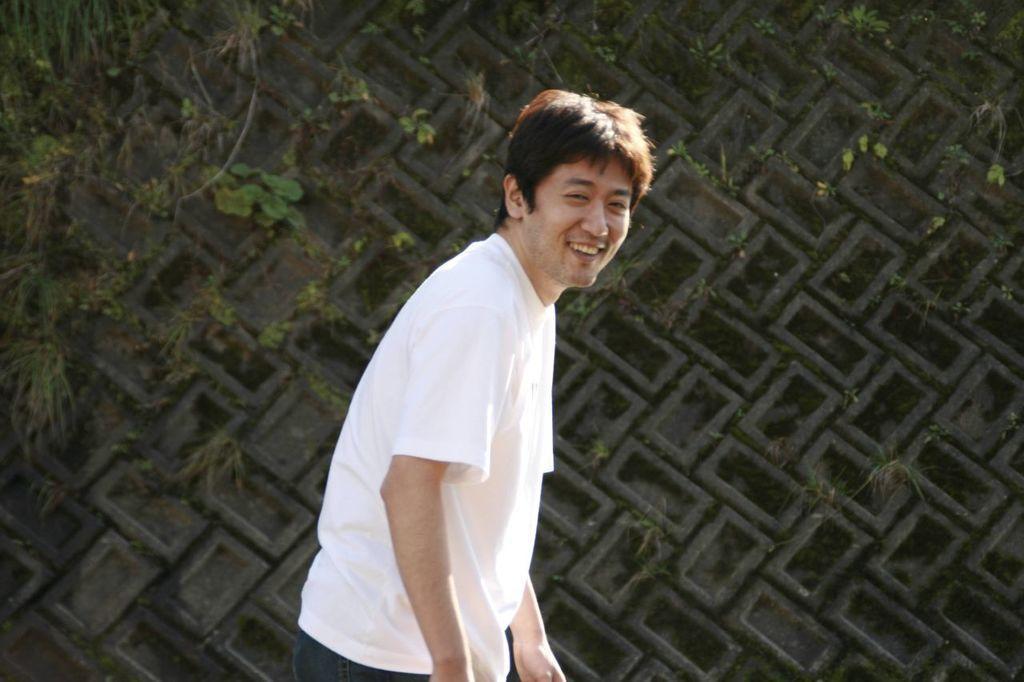Can you describe this image briefly? In the center of the image, we can see a person smiling and in the background, there is a tree and we can see a wall. 